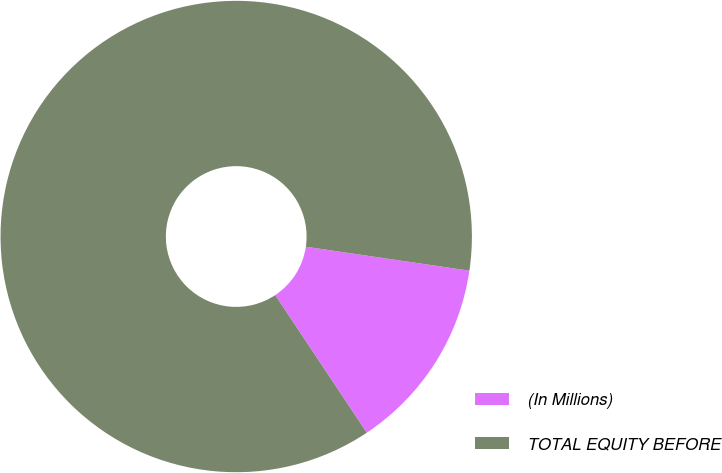Convert chart. <chart><loc_0><loc_0><loc_500><loc_500><pie_chart><fcel>(In Millions)<fcel>TOTAL EQUITY BEFORE<nl><fcel>13.34%<fcel>86.66%<nl></chart> 